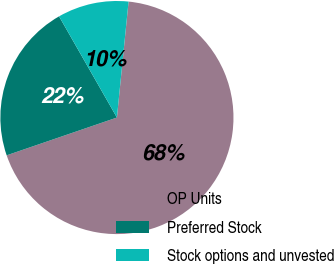<chart> <loc_0><loc_0><loc_500><loc_500><pie_chart><fcel>OP Units<fcel>Preferred Stock<fcel>Stock options and unvested<nl><fcel>68.16%<fcel>21.99%<fcel>9.86%<nl></chart> 